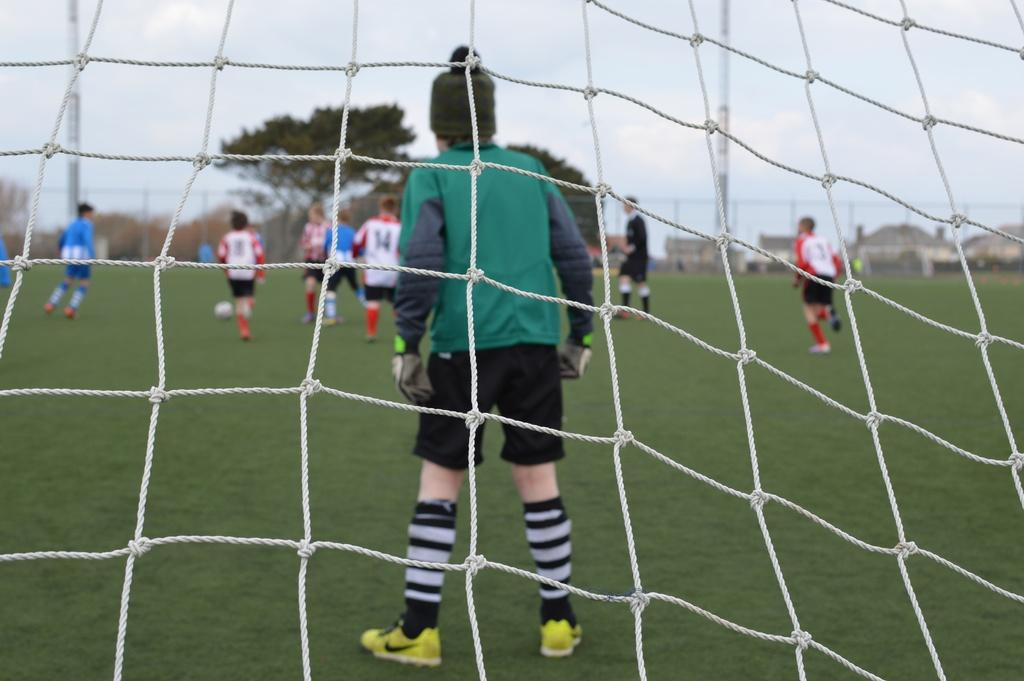<image>
Offer a succinct explanation of the picture presented. A soccer goal keeping standing in the goal looking over the field with another player with number 14 jersey in front of them. 